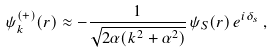Convert formula to latex. <formula><loc_0><loc_0><loc_500><loc_500>\psi _ { k } ^ { ( + ) } ( r ) \approx - \frac { 1 } { \sqrt { 2 \alpha ( k ^ { 2 } + \alpha ^ { 2 } ) } } \, \psi _ { S } ( r ) \, e ^ { i \delta _ { s } } \, ,</formula> 